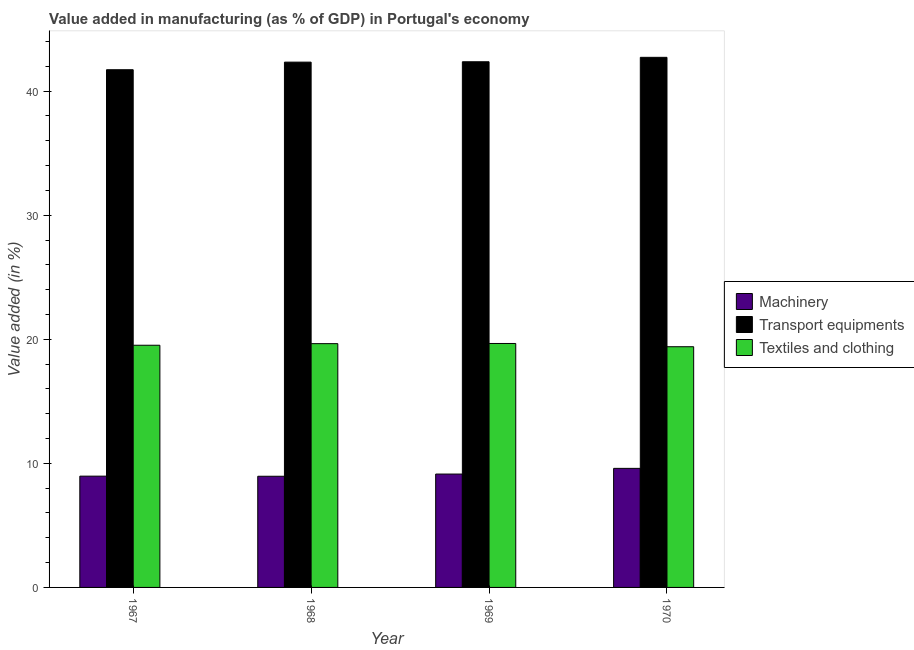How many different coloured bars are there?
Your answer should be very brief. 3. How many groups of bars are there?
Offer a very short reply. 4. Are the number of bars on each tick of the X-axis equal?
Keep it short and to the point. Yes. How many bars are there on the 4th tick from the left?
Ensure brevity in your answer.  3. How many bars are there on the 2nd tick from the right?
Provide a short and direct response. 3. What is the label of the 2nd group of bars from the left?
Make the answer very short. 1968. What is the value added in manufacturing machinery in 1969?
Your answer should be compact. 9.14. Across all years, what is the maximum value added in manufacturing textile and clothing?
Your answer should be very brief. 19.66. Across all years, what is the minimum value added in manufacturing textile and clothing?
Your answer should be compact. 19.4. In which year was the value added in manufacturing machinery maximum?
Ensure brevity in your answer.  1970. In which year was the value added in manufacturing machinery minimum?
Your response must be concise. 1968. What is the total value added in manufacturing machinery in the graph?
Ensure brevity in your answer.  36.66. What is the difference between the value added in manufacturing machinery in 1968 and that in 1970?
Your answer should be very brief. -0.64. What is the difference between the value added in manufacturing machinery in 1970 and the value added in manufacturing textile and clothing in 1968?
Offer a terse response. 0.64. What is the average value added in manufacturing transport equipments per year?
Keep it short and to the point. 42.29. In how many years, is the value added in manufacturing machinery greater than 32 %?
Ensure brevity in your answer.  0. What is the ratio of the value added in manufacturing textile and clothing in 1968 to that in 1969?
Your answer should be very brief. 1. Is the value added in manufacturing machinery in 1968 less than that in 1970?
Your answer should be very brief. Yes. Is the difference between the value added in manufacturing transport equipments in 1968 and 1970 greater than the difference between the value added in manufacturing textile and clothing in 1968 and 1970?
Make the answer very short. No. What is the difference between the highest and the second highest value added in manufacturing textile and clothing?
Offer a very short reply. 0.01. What is the difference between the highest and the lowest value added in manufacturing machinery?
Keep it short and to the point. 0.64. Is the sum of the value added in manufacturing textile and clothing in 1967 and 1968 greater than the maximum value added in manufacturing machinery across all years?
Ensure brevity in your answer.  Yes. What does the 1st bar from the left in 1967 represents?
Your answer should be very brief. Machinery. What does the 3rd bar from the right in 1968 represents?
Provide a succinct answer. Machinery. Is it the case that in every year, the sum of the value added in manufacturing machinery and value added in manufacturing transport equipments is greater than the value added in manufacturing textile and clothing?
Offer a very short reply. Yes. How many bars are there?
Your answer should be very brief. 12. Are all the bars in the graph horizontal?
Give a very brief answer. No. How many years are there in the graph?
Make the answer very short. 4. Does the graph contain grids?
Give a very brief answer. No. Where does the legend appear in the graph?
Ensure brevity in your answer.  Center right. How many legend labels are there?
Give a very brief answer. 3. How are the legend labels stacked?
Ensure brevity in your answer.  Vertical. What is the title of the graph?
Ensure brevity in your answer.  Value added in manufacturing (as % of GDP) in Portugal's economy. What is the label or title of the Y-axis?
Offer a very short reply. Value added (in %). What is the Value added (in %) in Machinery in 1967?
Your response must be concise. 8.97. What is the Value added (in %) in Transport equipments in 1967?
Make the answer very short. 41.72. What is the Value added (in %) of Textiles and clothing in 1967?
Provide a short and direct response. 19.52. What is the Value added (in %) in Machinery in 1968?
Your response must be concise. 8.96. What is the Value added (in %) of Transport equipments in 1968?
Your answer should be compact. 42.34. What is the Value added (in %) in Textiles and clothing in 1968?
Give a very brief answer. 19.65. What is the Value added (in %) of Machinery in 1969?
Keep it short and to the point. 9.14. What is the Value added (in %) in Transport equipments in 1969?
Your answer should be compact. 42.37. What is the Value added (in %) of Textiles and clothing in 1969?
Provide a short and direct response. 19.66. What is the Value added (in %) in Machinery in 1970?
Offer a very short reply. 9.6. What is the Value added (in %) in Transport equipments in 1970?
Provide a succinct answer. 42.72. What is the Value added (in %) in Textiles and clothing in 1970?
Give a very brief answer. 19.4. Across all years, what is the maximum Value added (in %) in Machinery?
Give a very brief answer. 9.6. Across all years, what is the maximum Value added (in %) of Transport equipments?
Keep it short and to the point. 42.72. Across all years, what is the maximum Value added (in %) in Textiles and clothing?
Provide a succinct answer. 19.66. Across all years, what is the minimum Value added (in %) in Machinery?
Offer a very short reply. 8.96. Across all years, what is the minimum Value added (in %) of Transport equipments?
Provide a short and direct response. 41.72. Across all years, what is the minimum Value added (in %) in Textiles and clothing?
Your response must be concise. 19.4. What is the total Value added (in %) of Machinery in the graph?
Provide a succinct answer. 36.66. What is the total Value added (in %) of Transport equipments in the graph?
Provide a short and direct response. 169.15. What is the total Value added (in %) of Textiles and clothing in the graph?
Provide a succinct answer. 78.23. What is the difference between the Value added (in %) of Machinery in 1967 and that in 1968?
Your answer should be very brief. 0.01. What is the difference between the Value added (in %) of Transport equipments in 1967 and that in 1968?
Your answer should be very brief. -0.61. What is the difference between the Value added (in %) in Textiles and clothing in 1967 and that in 1968?
Your response must be concise. -0.13. What is the difference between the Value added (in %) of Machinery in 1967 and that in 1969?
Ensure brevity in your answer.  -0.17. What is the difference between the Value added (in %) in Transport equipments in 1967 and that in 1969?
Ensure brevity in your answer.  -0.64. What is the difference between the Value added (in %) of Textiles and clothing in 1967 and that in 1969?
Make the answer very short. -0.14. What is the difference between the Value added (in %) of Machinery in 1967 and that in 1970?
Your answer should be very brief. -0.63. What is the difference between the Value added (in %) of Transport equipments in 1967 and that in 1970?
Your answer should be very brief. -1. What is the difference between the Value added (in %) of Textiles and clothing in 1967 and that in 1970?
Ensure brevity in your answer.  0.12. What is the difference between the Value added (in %) of Machinery in 1968 and that in 1969?
Make the answer very short. -0.18. What is the difference between the Value added (in %) in Transport equipments in 1968 and that in 1969?
Your answer should be very brief. -0.03. What is the difference between the Value added (in %) of Textiles and clothing in 1968 and that in 1969?
Keep it short and to the point. -0.01. What is the difference between the Value added (in %) in Machinery in 1968 and that in 1970?
Give a very brief answer. -0.64. What is the difference between the Value added (in %) of Transport equipments in 1968 and that in 1970?
Your answer should be compact. -0.39. What is the difference between the Value added (in %) in Textiles and clothing in 1968 and that in 1970?
Offer a terse response. 0.25. What is the difference between the Value added (in %) of Machinery in 1969 and that in 1970?
Offer a very short reply. -0.46. What is the difference between the Value added (in %) of Transport equipments in 1969 and that in 1970?
Give a very brief answer. -0.36. What is the difference between the Value added (in %) of Textiles and clothing in 1969 and that in 1970?
Give a very brief answer. 0.26. What is the difference between the Value added (in %) in Machinery in 1967 and the Value added (in %) in Transport equipments in 1968?
Offer a very short reply. -33.37. What is the difference between the Value added (in %) in Machinery in 1967 and the Value added (in %) in Textiles and clothing in 1968?
Your answer should be compact. -10.68. What is the difference between the Value added (in %) in Transport equipments in 1967 and the Value added (in %) in Textiles and clothing in 1968?
Provide a short and direct response. 22.08. What is the difference between the Value added (in %) of Machinery in 1967 and the Value added (in %) of Transport equipments in 1969?
Keep it short and to the point. -33.4. What is the difference between the Value added (in %) of Machinery in 1967 and the Value added (in %) of Textiles and clothing in 1969?
Make the answer very short. -10.69. What is the difference between the Value added (in %) of Transport equipments in 1967 and the Value added (in %) of Textiles and clothing in 1969?
Provide a short and direct response. 22.06. What is the difference between the Value added (in %) in Machinery in 1967 and the Value added (in %) in Transport equipments in 1970?
Offer a very short reply. -33.75. What is the difference between the Value added (in %) in Machinery in 1967 and the Value added (in %) in Textiles and clothing in 1970?
Ensure brevity in your answer.  -10.43. What is the difference between the Value added (in %) of Transport equipments in 1967 and the Value added (in %) of Textiles and clothing in 1970?
Offer a terse response. 22.32. What is the difference between the Value added (in %) of Machinery in 1968 and the Value added (in %) of Transport equipments in 1969?
Provide a short and direct response. -33.41. What is the difference between the Value added (in %) of Machinery in 1968 and the Value added (in %) of Textiles and clothing in 1969?
Provide a succinct answer. -10.7. What is the difference between the Value added (in %) of Transport equipments in 1968 and the Value added (in %) of Textiles and clothing in 1969?
Your response must be concise. 22.67. What is the difference between the Value added (in %) of Machinery in 1968 and the Value added (in %) of Transport equipments in 1970?
Give a very brief answer. -33.76. What is the difference between the Value added (in %) in Machinery in 1968 and the Value added (in %) in Textiles and clothing in 1970?
Offer a very short reply. -10.44. What is the difference between the Value added (in %) of Transport equipments in 1968 and the Value added (in %) of Textiles and clothing in 1970?
Offer a terse response. 22.94. What is the difference between the Value added (in %) of Machinery in 1969 and the Value added (in %) of Transport equipments in 1970?
Offer a very short reply. -33.59. What is the difference between the Value added (in %) in Machinery in 1969 and the Value added (in %) in Textiles and clothing in 1970?
Your response must be concise. -10.26. What is the difference between the Value added (in %) in Transport equipments in 1969 and the Value added (in %) in Textiles and clothing in 1970?
Offer a terse response. 22.97. What is the average Value added (in %) of Machinery per year?
Provide a succinct answer. 9.16. What is the average Value added (in %) of Transport equipments per year?
Keep it short and to the point. 42.29. What is the average Value added (in %) of Textiles and clothing per year?
Provide a succinct answer. 19.56. In the year 1967, what is the difference between the Value added (in %) in Machinery and Value added (in %) in Transport equipments?
Offer a terse response. -32.76. In the year 1967, what is the difference between the Value added (in %) of Machinery and Value added (in %) of Textiles and clothing?
Give a very brief answer. -10.55. In the year 1967, what is the difference between the Value added (in %) in Transport equipments and Value added (in %) in Textiles and clothing?
Your response must be concise. 22.21. In the year 1968, what is the difference between the Value added (in %) in Machinery and Value added (in %) in Transport equipments?
Your answer should be very brief. -33.38. In the year 1968, what is the difference between the Value added (in %) in Machinery and Value added (in %) in Textiles and clothing?
Your answer should be very brief. -10.69. In the year 1968, what is the difference between the Value added (in %) in Transport equipments and Value added (in %) in Textiles and clothing?
Make the answer very short. 22.69. In the year 1969, what is the difference between the Value added (in %) of Machinery and Value added (in %) of Transport equipments?
Offer a very short reply. -33.23. In the year 1969, what is the difference between the Value added (in %) in Machinery and Value added (in %) in Textiles and clothing?
Offer a terse response. -10.52. In the year 1969, what is the difference between the Value added (in %) in Transport equipments and Value added (in %) in Textiles and clothing?
Your answer should be very brief. 22.7. In the year 1970, what is the difference between the Value added (in %) in Machinery and Value added (in %) in Transport equipments?
Your answer should be very brief. -33.13. In the year 1970, what is the difference between the Value added (in %) in Machinery and Value added (in %) in Textiles and clothing?
Your answer should be compact. -9.8. In the year 1970, what is the difference between the Value added (in %) in Transport equipments and Value added (in %) in Textiles and clothing?
Offer a very short reply. 23.32. What is the ratio of the Value added (in %) of Machinery in 1967 to that in 1968?
Give a very brief answer. 1. What is the ratio of the Value added (in %) of Transport equipments in 1967 to that in 1968?
Provide a succinct answer. 0.99. What is the ratio of the Value added (in %) of Machinery in 1967 to that in 1969?
Your answer should be very brief. 0.98. What is the ratio of the Value added (in %) in Transport equipments in 1967 to that in 1969?
Your answer should be compact. 0.98. What is the ratio of the Value added (in %) in Machinery in 1967 to that in 1970?
Offer a very short reply. 0.93. What is the ratio of the Value added (in %) in Transport equipments in 1967 to that in 1970?
Your response must be concise. 0.98. What is the ratio of the Value added (in %) in Machinery in 1968 to that in 1969?
Make the answer very short. 0.98. What is the ratio of the Value added (in %) in Textiles and clothing in 1968 to that in 1969?
Keep it short and to the point. 1. What is the ratio of the Value added (in %) of Machinery in 1968 to that in 1970?
Provide a succinct answer. 0.93. What is the ratio of the Value added (in %) in Transport equipments in 1968 to that in 1970?
Your response must be concise. 0.99. What is the ratio of the Value added (in %) of Textiles and clothing in 1968 to that in 1970?
Make the answer very short. 1.01. What is the ratio of the Value added (in %) in Machinery in 1969 to that in 1970?
Ensure brevity in your answer.  0.95. What is the ratio of the Value added (in %) in Textiles and clothing in 1969 to that in 1970?
Give a very brief answer. 1.01. What is the difference between the highest and the second highest Value added (in %) in Machinery?
Give a very brief answer. 0.46. What is the difference between the highest and the second highest Value added (in %) in Transport equipments?
Provide a short and direct response. 0.36. What is the difference between the highest and the second highest Value added (in %) in Textiles and clothing?
Provide a short and direct response. 0.01. What is the difference between the highest and the lowest Value added (in %) in Machinery?
Provide a short and direct response. 0.64. What is the difference between the highest and the lowest Value added (in %) in Transport equipments?
Your answer should be very brief. 1. What is the difference between the highest and the lowest Value added (in %) in Textiles and clothing?
Provide a short and direct response. 0.26. 